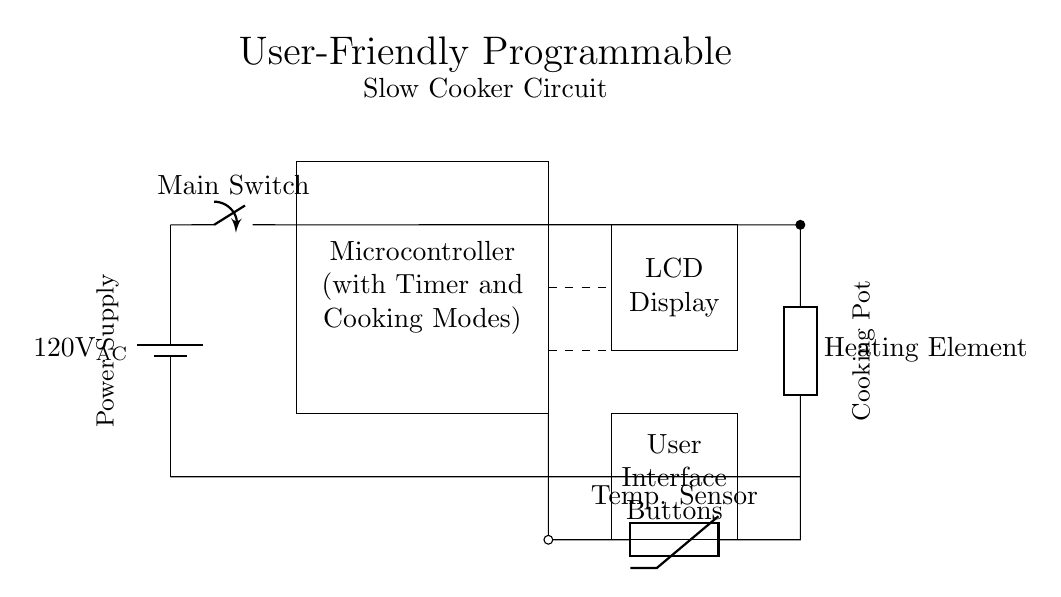What type of microcontroller is used in this circuit? The circuit diagram indicates that a microcontroller with timer and cooking modes is included, which manages the slow cooker functions.
Answer: Microcontroller with timer and cooking modes What component is used to display the cooking settings? The circuit features an LCD display, which is used for showing the user interface and current cooking settings.
Answer: LCD display What is the voltage of the power supply in this circuit? The diagram specifies that the power supply voltage is 120 volts AC, as indicated by the battery symbol at the start of the circuit.
Answer: 120 volts AC How many buttons are shown in the user interface section? The user interface section is denoted but the exact number of buttons is not specified in the diagram. However, it implies that there are multiple buttons, as it is labeled "User Interface Buttons".
Answer: Multiple buttons What is the purpose of the temperature sensor? The temperature sensor, shown as a thermistor connected to the microcontroller, is meant to monitor and provide feedback on the cooking temperature to the microcontroller for optimal cooking control.
Answer: Monitor cooking temperature Why is a heating element included in this circuit? The heating element is essential in a slow cooker circuit as it generates heat to cook food. This component is directly connected to the power supply and controlled by the microcontroller.
Answer: To generate heat for cooking 